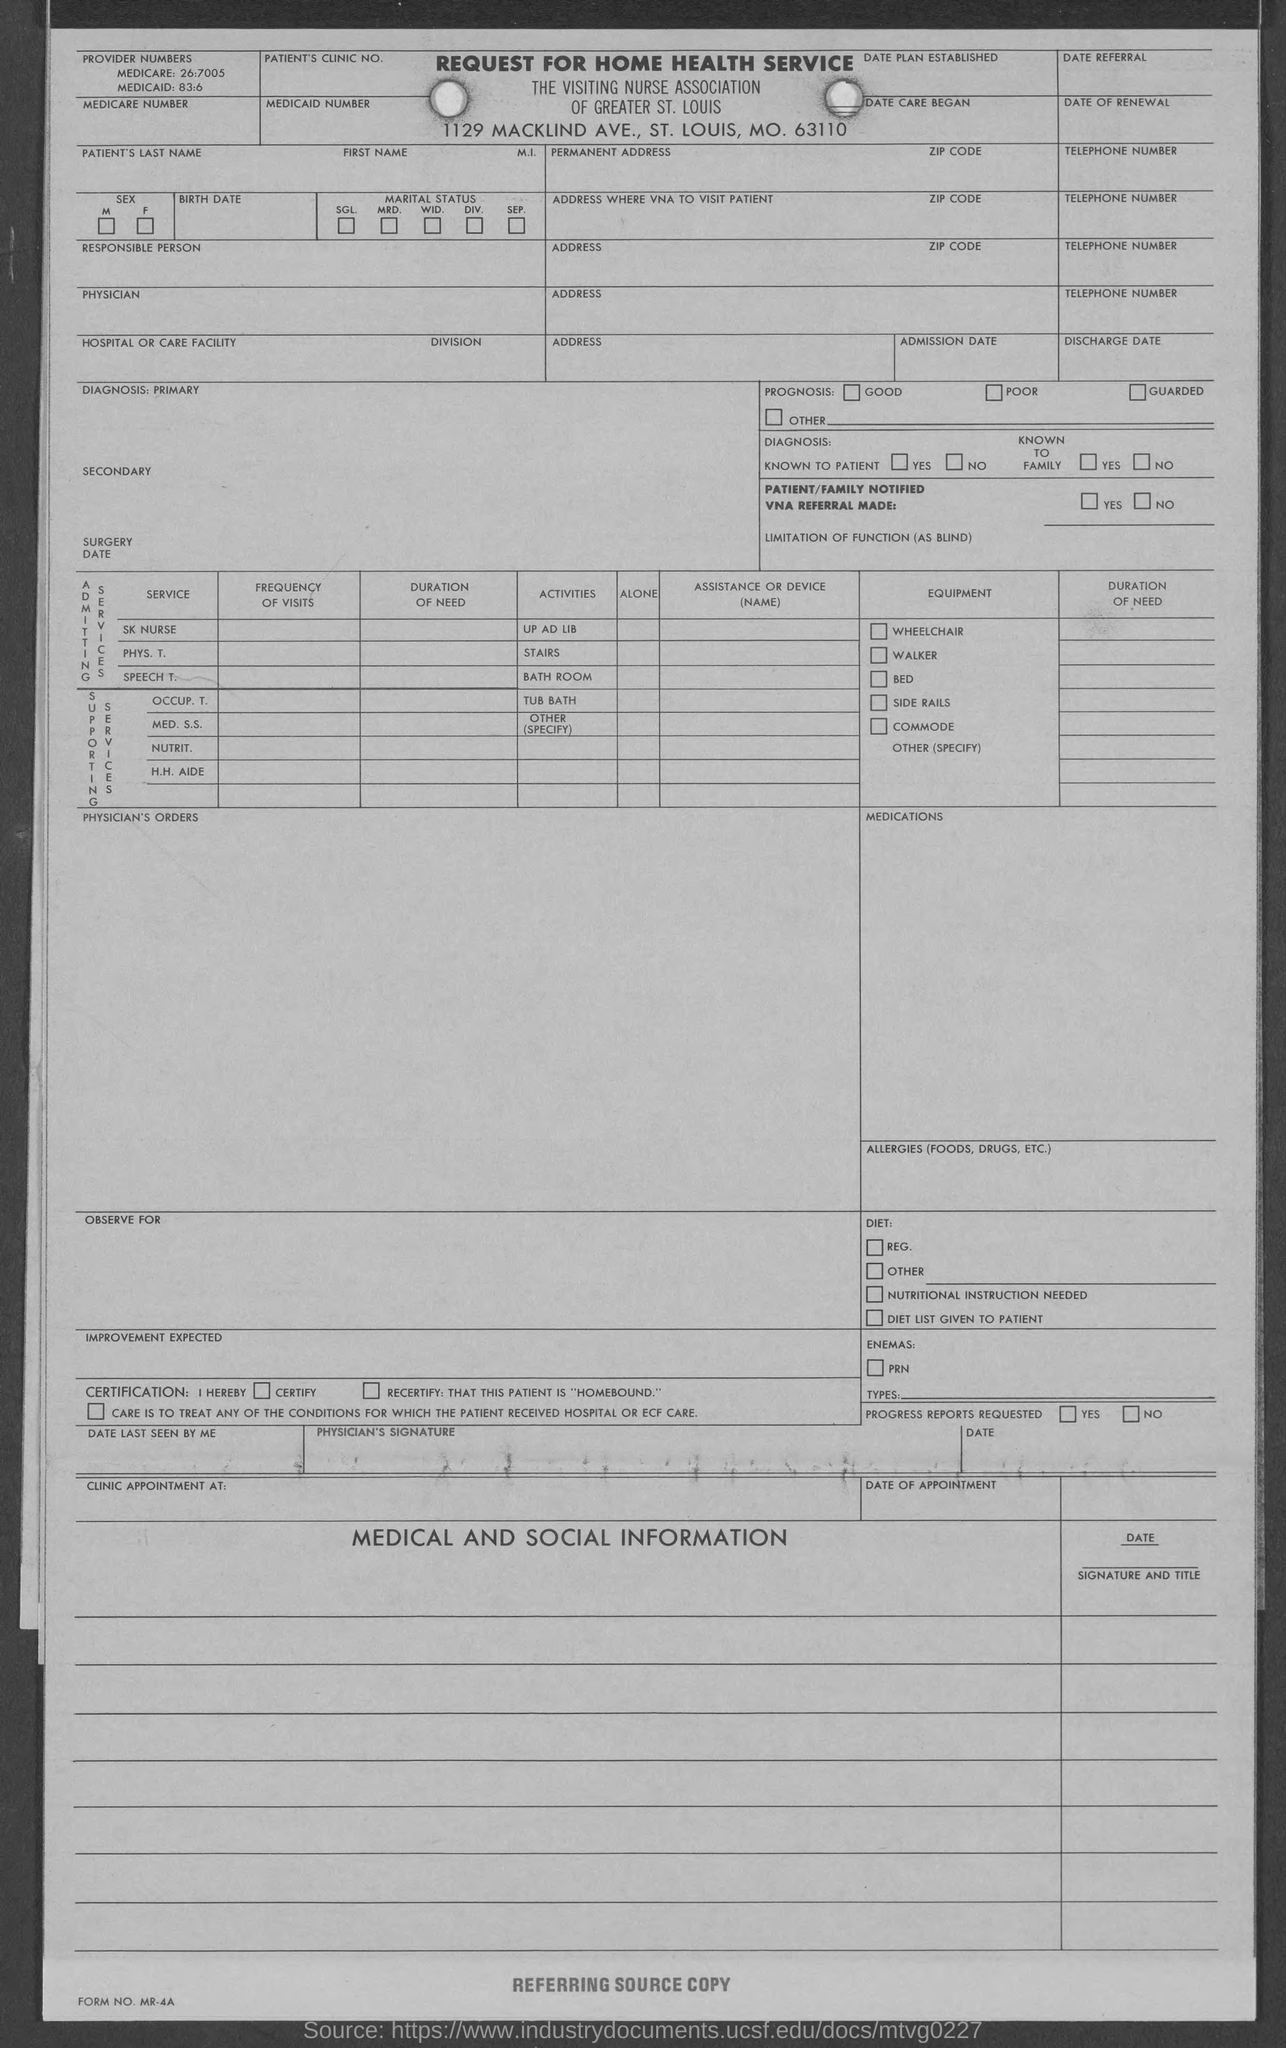What is the medicare number provided in the given form ?
Give a very brief answer. 26:7005. What is the medicaid number mentioned in the given form ?
Your answer should be very brief. 83:6. 